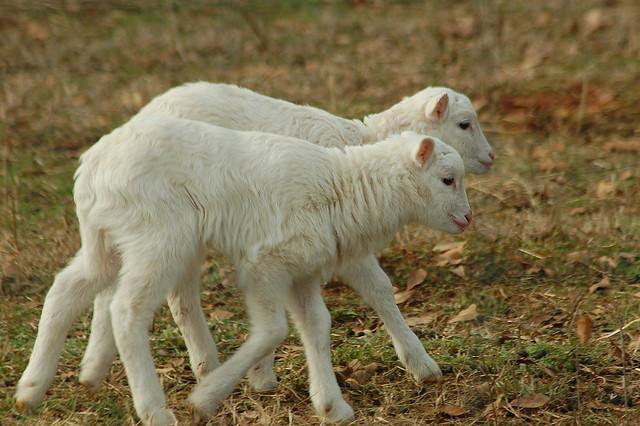How many legs are visible?
Give a very brief answer. 8. How many sheep can be seen?
Give a very brief answer. 2. 